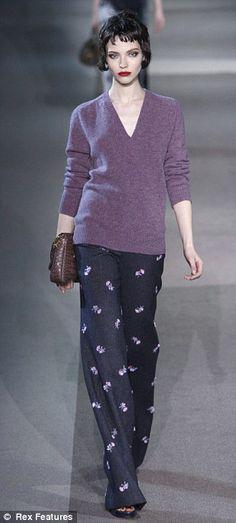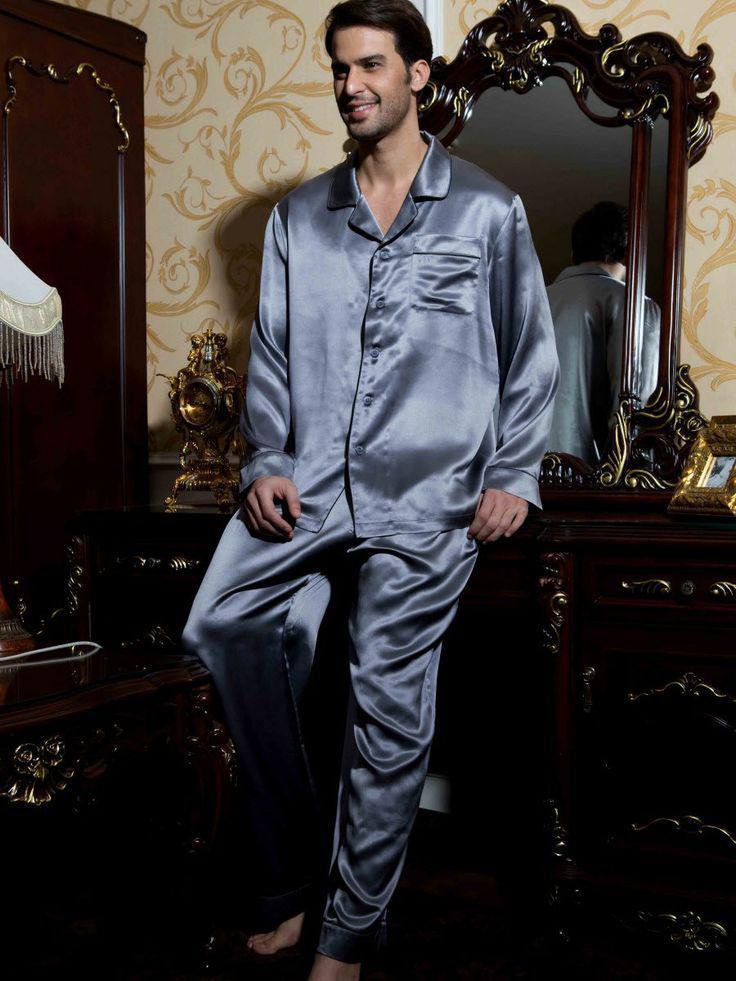The first image is the image on the left, the second image is the image on the right. Assess this claim about the two images: "A man is wearing plaid pajama pants in the image on the right.". Correct or not? Answer yes or no. No. The first image is the image on the left, the second image is the image on the right. Given the left and right images, does the statement "A man's silky diamond design pajama shirt has contrasting color at the collar, sleeve cuffs and pocket edge." hold true? Answer yes or no. No. 